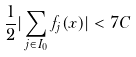<formula> <loc_0><loc_0><loc_500><loc_500>\frac { 1 } { 2 } | \sum _ { j \in I _ { 0 } } f _ { j } ( x ) | < 7 C</formula> 